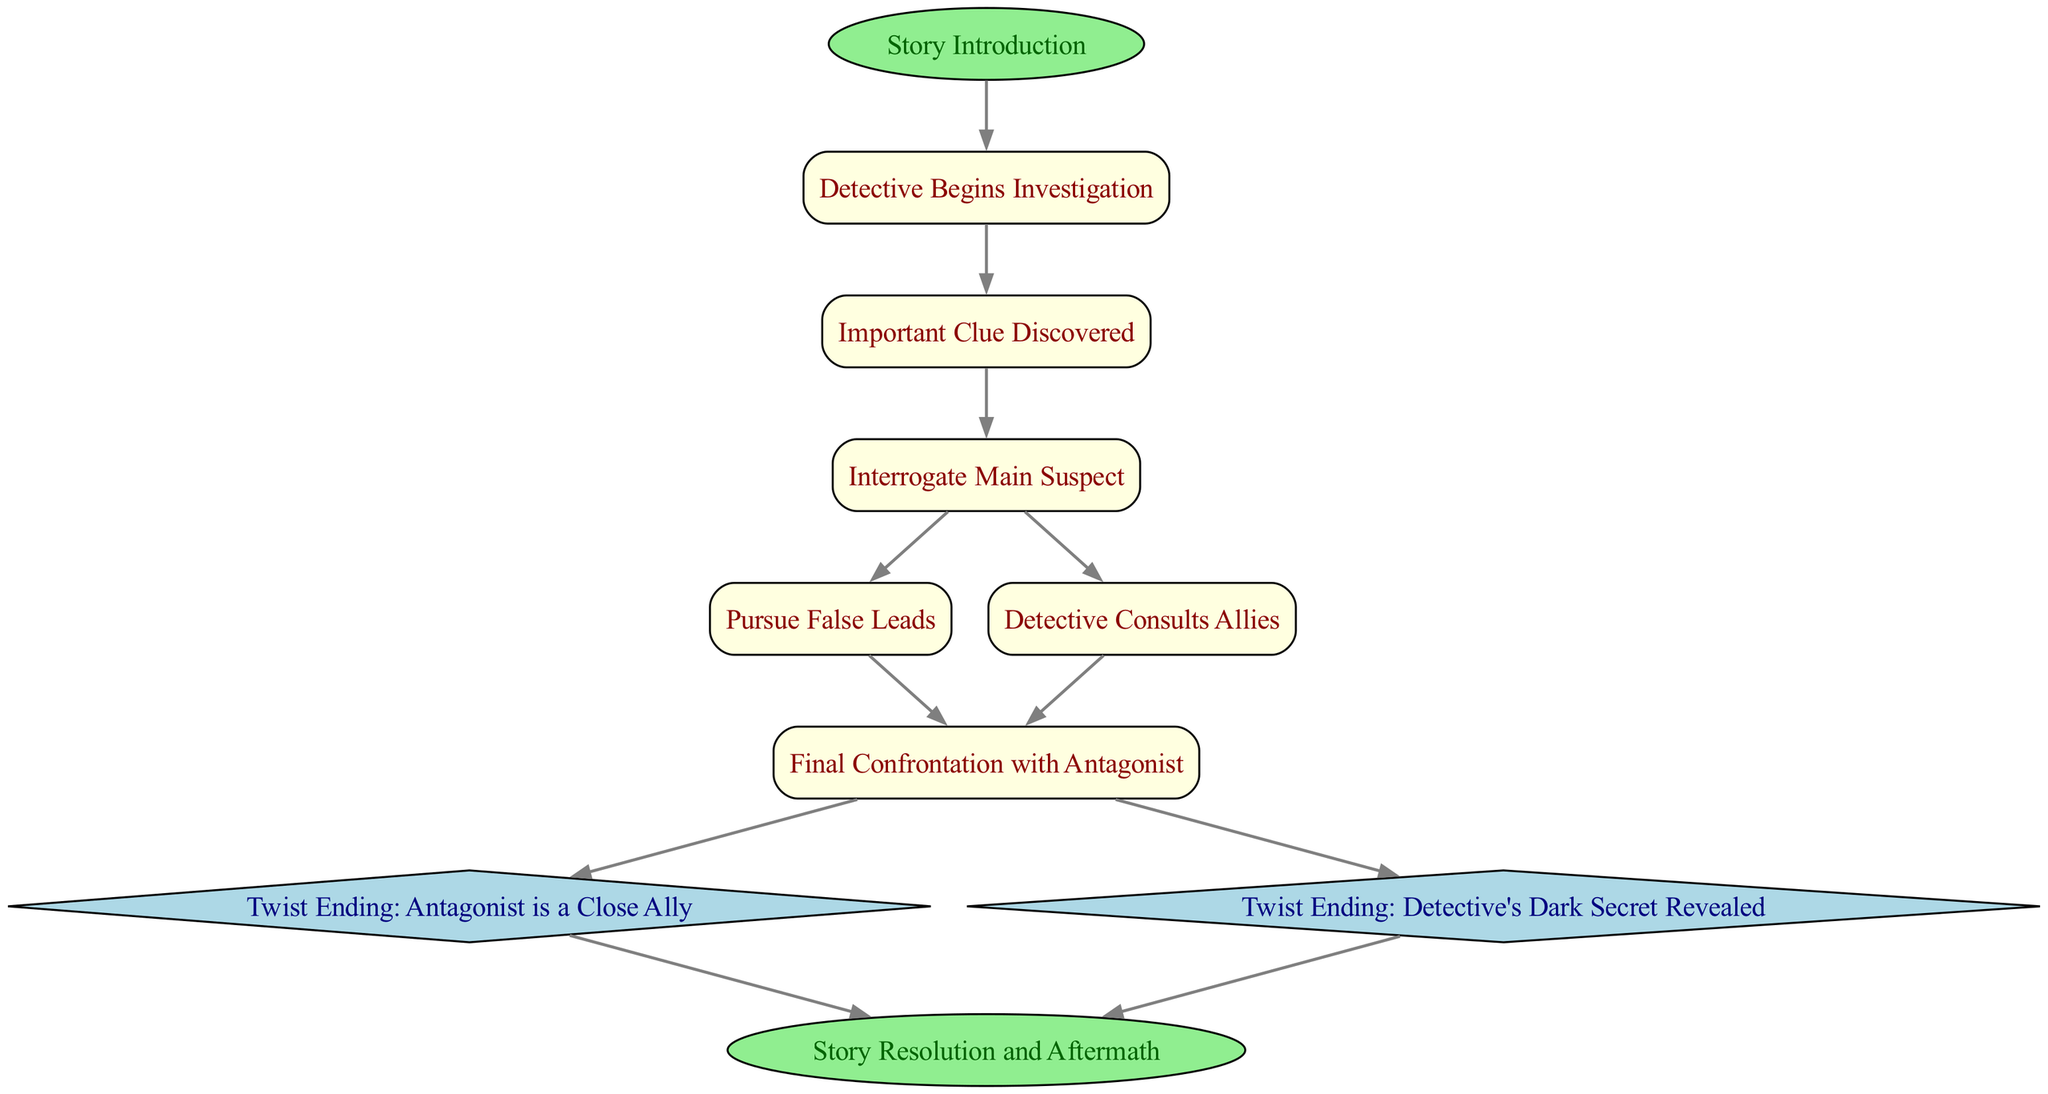What is the starting point of the decision pathway? The starting point in the diagram is indicated by the "Start" node, which represents the "Story Introduction" stage.
Answer: Story Introduction How many nodes are represented in the diagram? The diagram contains a total of 10 nodes, each representing a different stage or decision point in the thriller plot.
Answer: 10 Which node comes after "Suspect Interrogation"? Following "Suspect Interrogation," the diagram shows two possible next nodes: "False Lead" and "Allies," meaning the user can choose either of these paths.
Answer: False Lead and Allies What are the two twist endings provided in the plot? The nodes labeled "Twist Ending: Antagonist is a Close Ally" and "Twist Ending: Detective's Dark Secret Revealed" are the two twists that the story can lead to based on decisions made throughout the investigation.
Answer: Antagonist is a Close Ally, Detective's Dark Secret Revealed Which node leads directly to the resolution? The resolution of the story is reached through both "Twist Ending A" and "Twist Ending B," indicating that the story can conclude in different ways depending on the chosen path.
Answer: Twist Ending A and Twist Ending B What type of nodes are the twist endings categorized as? The twist endings in the diagram are marked as diamond-shaped nodes, which is a common representation for decision points or unique outcomes in directed graphs.
Answer: Diamond-shaped How many edges connect the "Confrontation" node to the twist endings? There are two edges leading from the "Confrontation" node to the twist endings, one for each specific twist ending provided in the plot.
Answer: 2 What action starts the detective's journey in the story? The action that initiates the detective's journey is represented by the "Detective Begins Investigation" node, which follows the "Story Introduction."
Answer: Detective Begins Investigation What color is used for the "Resolution" node? The "Resolution" node is colored light green, which visually distinguishes it from other nodes in the diagram.
Answer: Light green 